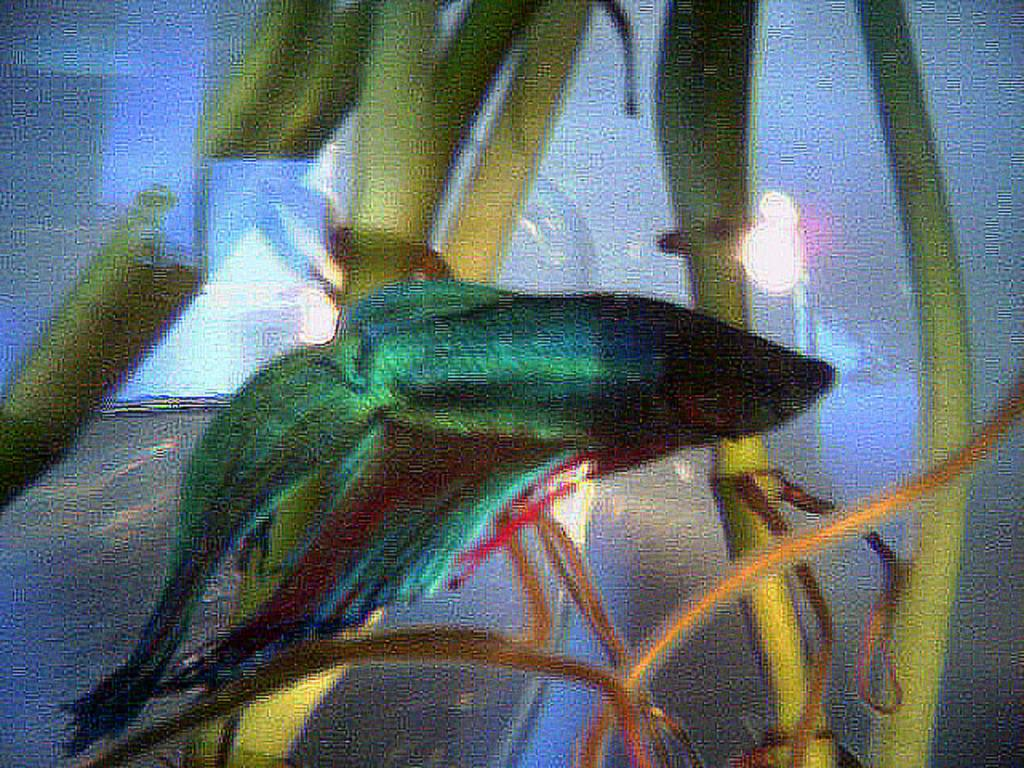What is the main feature of the image? There is an aquarium in the image. What can be found inside the aquarium? There is a fish in the aquarium. Are there any other elements in the aquarium besides the fish? Yes, there are plants in the aquarium. What type of pocket can be seen in the image? There is no pocket present in the image; it features an aquarium with a fish and plants. 